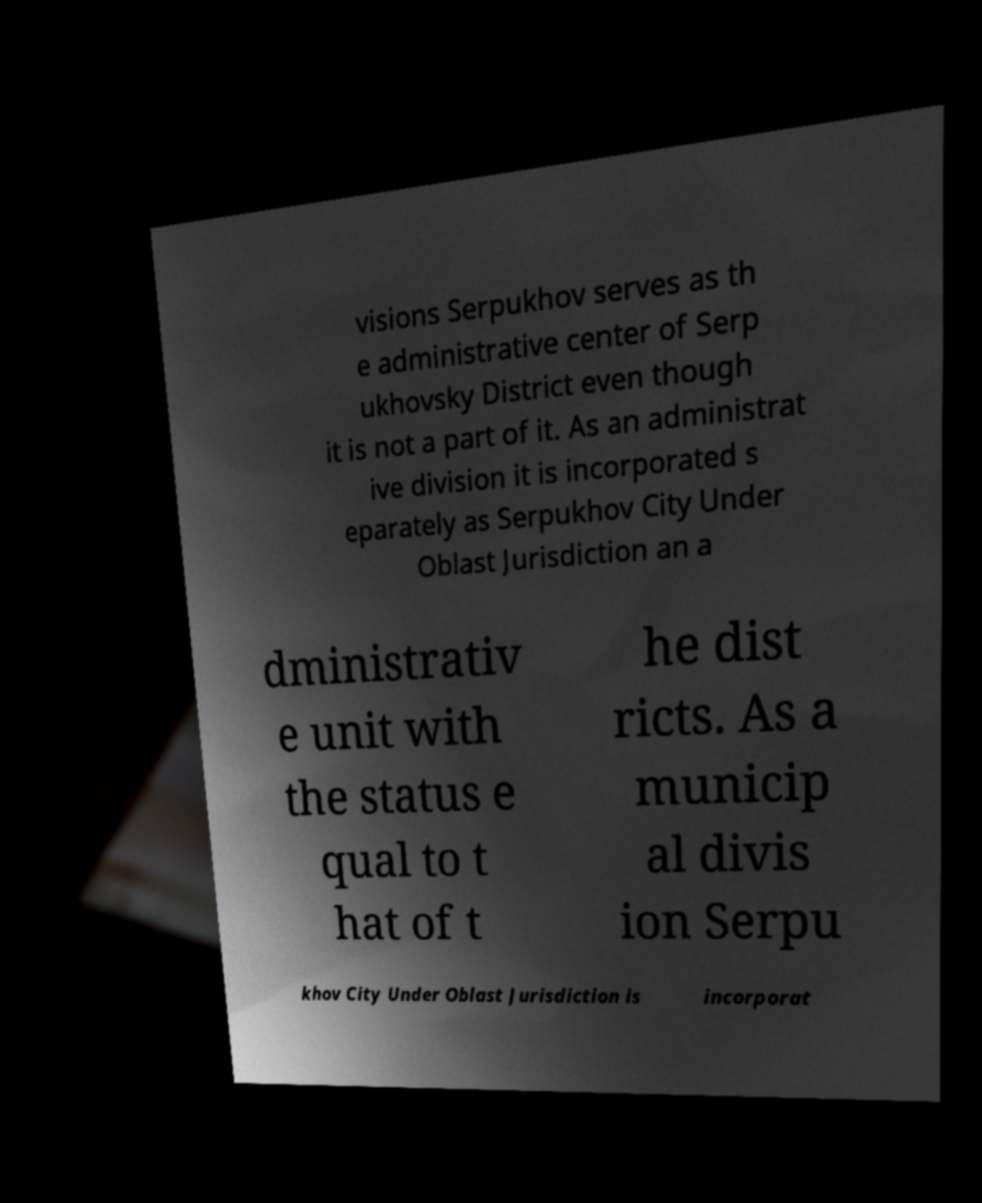Can you read and provide the text displayed in the image?This photo seems to have some interesting text. Can you extract and type it out for me? visions Serpukhov serves as th e administrative center of Serp ukhovsky District even though it is not a part of it. As an administrat ive division it is incorporated s eparately as Serpukhov City Under Oblast Jurisdiction an a dministrativ e unit with the status e qual to t hat of t he dist ricts. As a municip al divis ion Serpu khov City Under Oblast Jurisdiction is incorporat 